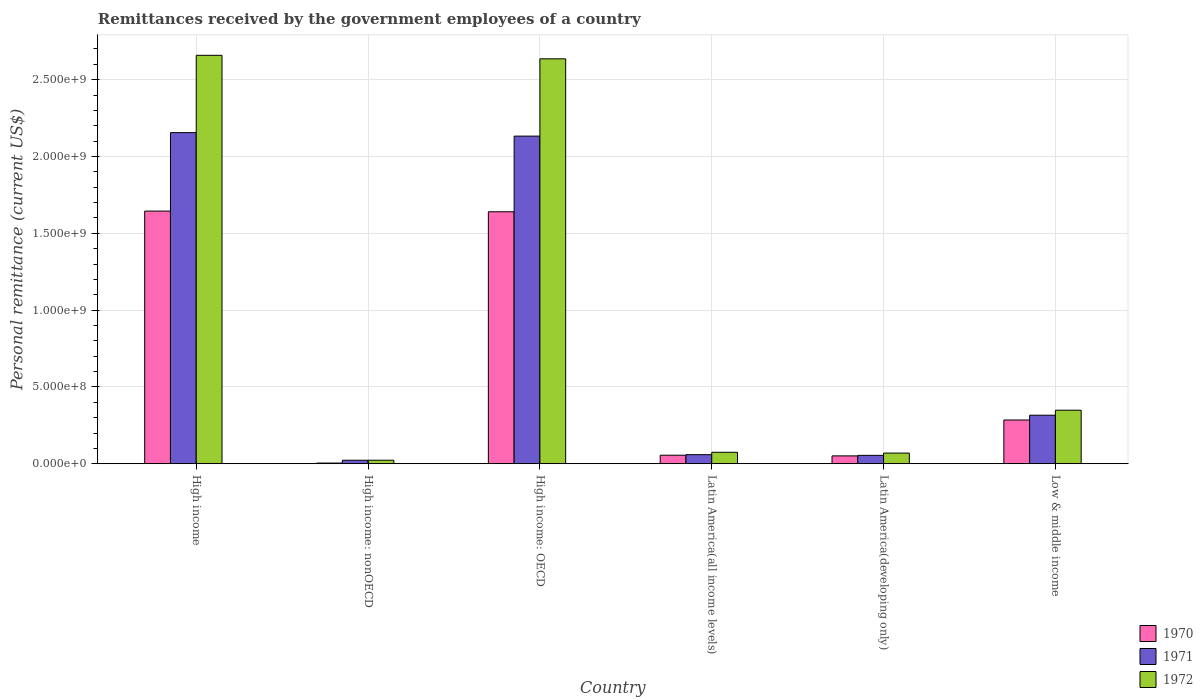Are the number of bars per tick equal to the number of legend labels?
Ensure brevity in your answer.  Yes. How many bars are there on the 4th tick from the right?
Your answer should be compact. 3. What is the label of the 5th group of bars from the left?
Provide a succinct answer. Latin America(developing only). What is the remittances received by the government employees in 1970 in High income: nonOECD?
Provide a succinct answer. 4.40e+06. Across all countries, what is the maximum remittances received by the government employees in 1971?
Keep it short and to the point. 2.16e+09. Across all countries, what is the minimum remittances received by the government employees in 1971?
Ensure brevity in your answer.  2.28e+07. In which country was the remittances received by the government employees in 1970 maximum?
Give a very brief answer. High income. In which country was the remittances received by the government employees in 1970 minimum?
Your answer should be very brief. High income: nonOECD. What is the total remittances received by the government employees in 1971 in the graph?
Give a very brief answer. 4.74e+09. What is the difference between the remittances received by the government employees in 1972 in High income: OECD and that in Latin America(all income levels)?
Your response must be concise. 2.56e+09. What is the difference between the remittances received by the government employees in 1972 in Latin America(developing only) and the remittances received by the government employees in 1971 in High income: OECD?
Your answer should be compact. -2.06e+09. What is the average remittances received by the government employees in 1972 per country?
Your answer should be very brief. 9.68e+08. What is the difference between the remittances received by the government employees of/in 1970 and remittances received by the government employees of/in 1972 in High income?
Your answer should be very brief. -1.01e+09. In how many countries, is the remittances received by the government employees in 1972 greater than 100000000 US$?
Offer a very short reply. 3. What is the ratio of the remittances received by the government employees in 1972 in High income to that in Latin America(developing only)?
Your answer should be very brief. 38.32. Is the remittances received by the government employees in 1970 in Latin America(all income levels) less than that in Low & middle income?
Provide a succinct answer. Yes. Is the difference between the remittances received by the government employees in 1970 in High income and Low & middle income greater than the difference between the remittances received by the government employees in 1972 in High income and Low & middle income?
Make the answer very short. No. What is the difference between the highest and the second highest remittances received by the government employees in 1970?
Make the answer very short. -1.36e+09. What is the difference between the highest and the lowest remittances received by the government employees in 1970?
Keep it short and to the point. 1.64e+09. Is the sum of the remittances received by the government employees in 1971 in High income and Latin America(all income levels) greater than the maximum remittances received by the government employees in 1972 across all countries?
Offer a terse response. No. What does the 1st bar from the left in Low & middle income represents?
Your answer should be very brief. 1970. Is it the case that in every country, the sum of the remittances received by the government employees in 1971 and remittances received by the government employees in 1970 is greater than the remittances received by the government employees in 1972?
Provide a short and direct response. Yes. How many bars are there?
Make the answer very short. 18. How many countries are there in the graph?
Ensure brevity in your answer.  6. What is the difference between two consecutive major ticks on the Y-axis?
Offer a very short reply. 5.00e+08. Are the values on the major ticks of Y-axis written in scientific E-notation?
Offer a terse response. Yes. Does the graph contain grids?
Give a very brief answer. Yes. Where does the legend appear in the graph?
Provide a succinct answer. Bottom right. How many legend labels are there?
Offer a terse response. 3. How are the legend labels stacked?
Your answer should be very brief. Vertical. What is the title of the graph?
Make the answer very short. Remittances received by the government employees of a country. What is the label or title of the X-axis?
Make the answer very short. Country. What is the label or title of the Y-axis?
Your answer should be very brief. Personal remittance (current US$). What is the Personal remittance (current US$) in 1970 in High income?
Provide a succinct answer. 1.64e+09. What is the Personal remittance (current US$) in 1971 in High income?
Give a very brief answer. 2.16e+09. What is the Personal remittance (current US$) of 1972 in High income?
Your answer should be compact. 2.66e+09. What is the Personal remittance (current US$) of 1970 in High income: nonOECD?
Give a very brief answer. 4.40e+06. What is the Personal remittance (current US$) of 1971 in High income: nonOECD?
Keep it short and to the point. 2.28e+07. What is the Personal remittance (current US$) of 1972 in High income: nonOECD?
Your response must be concise. 2.29e+07. What is the Personal remittance (current US$) in 1970 in High income: OECD?
Your answer should be compact. 1.64e+09. What is the Personal remittance (current US$) in 1971 in High income: OECD?
Offer a terse response. 2.13e+09. What is the Personal remittance (current US$) in 1972 in High income: OECD?
Provide a succinct answer. 2.64e+09. What is the Personal remittance (current US$) in 1970 in Latin America(all income levels)?
Ensure brevity in your answer.  5.55e+07. What is the Personal remittance (current US$) in 1971 in Latin America(all income levels)?
Give a very brief answer. 5.91e+07. What is the Personal remittance (current US$) in 1972 in Latin America(all income levels)?
Offer a terse response. 7.45e+07. What is the Personal remittance (current US$) in 1970 in Latin America(developing only)?
Your answer should be very brief. 5.11e+07. What is the Personal remittance (current US$) in 1971 in Latin America(developing only)?
Keep it short and to the point. 5.45e+07. What is the Personal remittance (current US$) of 1972 in Latin America(developing only)?
Make the answer very short. 6.94e+07. What is the Personal remittance (current US$) in 1970 in Low & middle income?
Your answer should be compact. 2.85e+08. What is the Personal remittance (current US$) of 1971 in Low & middle income?
Offer a terse response. 3.16e+08. What is the Personal remittance (current US$) in 1972 in Low & middle income?
Your answer should be compact. 3.48e+08. Across all countries, what is the maximum Personal remittance (current US$) of 1970?
Offer a terse response. 1.64e+09. Across all countries, what is the maximum Personal remittance (current US$) of 1971?
Your answer should be very brief. 2.16e+09. Across all countries, what is the maximum Personal remittance (current US$) in 1972?
Keep it short and to the point. 2.66e+09. Across all countries, what is the minimum Personal remittance (current US$) of 1970?
Ensure brevity in your answer.  4.40e+06. Across all countries, what is the minimum Personal remittance (current US$) in 1971?
Keep it short and to the point. 2.28e+07. Across all countries, what is the minimum Personal remittance (current US$) of 1972?
Offer a terse response. 2.29e+07. What is the total Personal remittance (current US$) of 1970 in the graph?
Keep it short and to the point. 3.68e+09. What is the total Personal remittance (current US$) of 1971 in the graph?
Your response must be concise. 4.74e+09. What is the total Personal remittance (current US$) in 1972 in the graph?
Offer a terse response. 5.81e+09. What is the difference between the Personal remittance (current US$) of 1970 in High income and that in High income: nonOECD?
Ensure brevity in your answer.  1.64e+09. What is the difference between the Personal remittance (current US$) in 1971 in High income and that in High income: nonOECD?
Provide a short and direct response. 2.13e+09. What is the difference between the Personal remittance (current US$) of 1972 in High income and that in High income: nonOECD?
Offer a very short reply. 2.64e+09. What is the difference between the Personal remittance (current US$) of 1970 in High income and that in High income: OECD?
Provide a succinct answer. 4.40e+06. What is the difference between the Personal remittance (current US$) in 1971 in High income and that in High income: OECD?
Keep it short and to the point. 2.28e+07. What is the difference between the Personal remittance (current US$) of 1972 in High income and that in High income: OECD?
Your answer should be very brief. 2.29e+07. What is the difference between the Personal remittance (current US$) in 1970 in High income and that in Latin America(all income levels)?
Your answer should be very brief. 1.59e+09. What is the difference between the Personal remittance (current US$) of 1971 in High income and that in Latin America(all income levels)?
Offer a terse response. 2.10e+09. What is the difference between the Personal remittance (current US$) in 1972 in High income and that in Latin America(all income levels)?
Offer a very short reply. 2.58e+09. What is the difference between the Personal remittance (current US$) in 1970 in High income and that in Latin America(developing only)?
Ensure brevity in your answer.  1.59e+09. What is the difference between the Personal remittance (current US$) in 1971 in High income and that in Latin America(developing only)?
Offer a very short reply. 2.10e+09. What is the difference between the Personal remittance (current US$) in 1972 in High income and that in Latin America(developing only)?
Ensure brevity in your answer.  2.59e+09. What is the difference between the Personal remittance (current US$) in 1970 in High income and that in Low & middle income?
Provide a short and direct response. 1.36e+09. What is the difference between the Personal remittance (current US$) in 1971 in High income and that in Low & middle income?
Offer a terse response. 1.84e+09. What is the difference between the Personal remittance (current US$) in 1972 in High income and that in Low & middle income?
Keep it short and to the point. 2.31e+09. What is the difference between the Personal remittance (current US$) in 1970 in High income: nonOECD and that in High income: OECD?
Provide a short and direct response. -1.64e+09. What is the difference between the Personal remittance (current US$) in 1971 in High income: nonOECD and that in High income: OECD?
Keep it short and to the point. -2.11e+09. What is the difference between the Personal remittance (current US$) of 1972 in High income: nonOECD and that in High income: OECD?
Offer a terse response. -2.61e+09. What is the difference between the Personal remittance (current US$) of 1970 in High income: nonOECD and that in Latin America(all income levels)?
Provide a short and direct response. -5.11e+07. What is the difference between the Personal remittance (current US$) of 1971 in High income: nonOECD and that in Latin America(all income levels)?
Offer a terse response. -3.63e+07. What is the difference between the Personal remittance (current US$) of 1972 in High income: nonOECD and that in Latin America(all income levels)?
Give a very brief answer. -5.16e+07. What is the difference between the Personal remittance (current US$) of 1970 in High income: nonOECD and that in Latin America(developing only)?
Provide a short and direct response. -4.67e+07. What is the difference between the Personal remittance (current US$) in 1971 in High income: nonOECD and that in Latin America(developing only)?
Make the answer very short. -3.17e+07. What is the difference between the Personal remittance (current US$) in 1972 in High income: nonOECD and that in Latin America(developing only)?
Offer a very short reply. -4.65e+07. What is the difference between the Personal remittance (current US$) in 1970 in High income: nonOECD and that in Low & middle income?
Keep it short and to the point. -2.80e+08. What is the difference between the Personal remittance (current US$) of 1971 in High income: nonOECD and that in Low & middle income?
Offer a very short reply. -2.93e+08. What is the difference between the Personal remittance (current US$) in 1972 in High income: nonOECD and that in Low & middle income?
Provide a succinct answer. -3.26e+08. What is the difference between the Personal remittance (current US$) of 1970 in High income: OECD and that in Latin America(all income levels)?
Your answer should be very brief. 1.58e+09. What is the difference between the Personal remittance (current US$) in 1971 in High income: OECD and that in Latin America(all income levels)?
Your answer should be very brief. 2.07e+09. What is the difference between the Personal remittance (current US$) in 1972 in High income: OECD and that in Latin America(all income levels)?
Your answer should be very brief. 2.56e+09. What is the difference between the Personal remittance (current US$) of 1970 in High income: OECD and that in Latin America(developing only)?
Ensure brevity in your answer.  1.59e+09. What is the difference between the Personal remittance (current US$) of 1971 in High income: OECD and that in Latin America(developing only)?
Your answer should be very brief. 2.08e+09. What is the difference between the Personal remittance (current US$) in 1972 in High income: OECD and that in Latin America(developing only)?
Your response must be concise. 2.57e+09. What is the difference between the Personal remittance (current US$) in 1970 in High income: OECD and that in Low & middle income?
Your answer should be compact. 1.36e+09. What is the difference between the Personal remittance (current US$) in 1971 in High income: OECD and that in Low & middle income?
Provide a succinct answer. 1.82e+09. What is the difference between the Personal remittance (current US$) of 1972 in High income: OECD and that in Low & middle income?
Keep it short and to the point. 2.29e+09. What is the difference between the Personal remittance (current US$) in 1970 in Latin America(all income levels) and that in Latin America(developing only)?
Provide a short and direct response. 4.40e+06. What is the difference between the Personal remittance (current US$) of 1971 in Latin America(all income levels) and that in Latin America(developing only)?
Give a very brief answer. 4.61e+06. What is the difference between the Personal remittance (current US$) of 1972 in Latin America(all income levels) and that in Latin America(developing only)?
Ensure brevity in your answer.  5.10e+06. What is the difference between the Personal remittance (current US$) in 1970 in Latin America(all income levels) and that in Low & middle income?
Make the answer very short. -2.29e+08. What is the difference between the Personal remittance (current US$) in 1971 in Latin America(all income levels) and that in Low & middle income?
Ensure brevity in your answer.  -2.57e+08. What is the difference between the Personal remittance (current US$) in 1972 in Latin America(all income levels) and that in Low & middle income?
Your answer should be very brief. -2.74e+08. What is the difference between the Personal remittance (current US$) in 1970 in Latin America(developing only) and that in Low & middle income?
Offer a terse response. -2.34e+08. What is the difference between the Personal remittance (current US$) of 1971 in Latin America(developing only) and that in Low & middle income?
Your answer should be compact. -2.61e+08. What is the difference between the Personal remittance (current US$) in 1972 in Latin America(developing only) and that in Low & middle income?
Keep it short and to the point. -2.79e+08. What is the difference between the Personal remittance (current US$) of 1970 in High income and the Personal remittance (current US$) of 1971 in High income: nonOECD?
Provide a short and direct response. 1.62e+09. What is the difference between the Personal remittance (current US$) of 1970 in High income and the Personal remittance (current US$) of 1972 in High income: nonOECD?
Provide a short and direct response. 1.62e+09. What is the difference between the Personal remittance (current US$) of 1971 in High income and the Personal remittance (current US$) of 1972 in High income: nonOECD?
Give a very brief answer. 2.13e+09. What is the difference between the Personal remittance (current US$) in 1970 in High income and the Personal remittance (current US$) in 1971 in High income: OECD?
Your answer should be compact. -4.88e+08. What is the difference between the Personal remittance (current US$) of 1970 in High income and the Personal remittance (current US$) of 1972 in High income: OECD?
Give a very brief answer. -9.91e+08. What is the difference between the Personal remittance (current US$) of 1971 in High income and the Personal remittance (current US$) of 1972 in High income: OECD?
Offer a terse response. -4.80e+08. What is the difference between the Personal remittance (current US$) in 1970 in High income and the Personal remittance (current US$) in 1971 in Latin America(all income levels)?
Ensure brevity in your answer.  1.59e+09. What is the difference between the Personal remittance (current US$) in 1970 in High income and the Personal remittance (current US$) in 1972 in Latin America(all income levels)?
Offer a terse response. 1.57e+09. What is the difference between the Personal remittance (current US$) of 1971 in High income and the Personal remittance (current US$) of 1972 in Latin America(all income levels)?
Your answer should be very brief. 2.08e+09. What is the difference between the Personal remittance (current US$) in 1970 in High income and the Personal remittance (current US$) in 1971 in Latin America(developing only)?
Offer a very short reply. 1.59e+09. What is the difference between the Personal remittance (current US$) in 1970 in High income and the Personal remittance (current US$) in 1972 in Latin America(developing only)?
Offer a terse response. 1.58e+09. What is the difference between the Personal remittance (current US$) of 1971 in High income and the Personal remittance (current US$) of 1972 in Latin America(developing only)?
Offer a very short reply. 2.09e+09. What is the difference between the Personal remittance (current US$) in 1970 in High income and the Personal remittance (current US$) in 1971 in Low & middle income?
Your response must be concise. 1.33e+09. What is the difference between the Personal remittance (current US$) of 1970 in High income and the Personal remittance (current US$) of 1972 in Low & middle income?
Ensure brevity in your answer.  1.30e+09. What is the difference between the Personal remittance (current US$) of 1971 in High income and the Personal remittance (current US$) of 1972 in Low & middle income?
Your answer should be very brief. 1.81e+09. What is the difference between the Personal remittance (current US$) of 1970 in High income: nonOECD and the Personal remittance (current US$) of 1971 in High income: OECD?
Your response must be concise. -2.13e+09. What is the difference between the Personal remittance (current US$) of 1970 in High income: nonOECD and the Personal remittance (current US$) of 1972 in High income: OECD?
Your response must be concise. -2.63e+09. What is the difference between the Personal remittance (current US$) of 1971 in High income: nonOECD and the Personal remittance (current US$) of 1972 in High income: OECD?
Provide a short and direct response. -2.61e+09. What is the difference between the Personal remittance (current US$) of 1970 in High income: nonOECD and the Personal remittance (current US$) of 1971 in Latin America(all income levels)?
Your response must be concise. -5.47e+07. What is the difference between the Personal remittance (current US$) of 1970 in High income: nonOECD and the Personal remittance (current US$) of 1972 in Latin America(all income levels)?
Give a very brief answer. -7.01e+07. What is the difference between the Personal remittance (current US$) in 1971 in High income: nonOECD and the Personal remittance (current US$) in 1972 in Latin America(all income levels)?
Give a very brief answer. -5.17e+07. What is the difference between the Personal remittance (current US$) in 1970 in High income: nonOECD and the Personal remittance (current US$) in 1971 in Latin America(developing only)?
Your response must be concise. -5.01e+07. What is the difference between the Personal remittance (current US$) in 1970 in High income: nonOECD and the Personal remittance (current US$) in 1972 in Latin America(developing only)?
Give a very brief answer. -6.50e+07. What is the difference between the Personal remittance (current US$) of 1971 in High income: nonOECD and the Personal remittance (current US$) of 1972 in Latin America(developing only)?
Give a very brief answer. -4.66e+07. What is the difference between the Personal remittance (current US$) in 1970 in High income: nonOECD and the Personal remittance (current US$) in 1971 in Low & middle income?
Give a very brief answer. -3.11e+08. What is the difference between the Personal remittance (current US$) in 1970 in High income: nonOECD and the Personal remittance (current US$) in 1972 in Low & middle income?
Your answer should be compact. -3.44e+08. What is the difference between the Personal remittance (current US$) of 1971 in High income: nonOECD and the Personal remittance (current US$) of 1972 in Low & middle income?
Keep it short and to the point. -3.26e+08. What is the difference between the Personal remittance (current US$) in 1970 in High income: OECD and the Personal remittance (current US$) in 1971 in Latin America(all income levels)?
Give a very brief answer. 1.58e+09. What is the difference between the Personal remittance (current US$) in 1970 in High income: OECD and the Personal remittance (current US$) in 1972 in Latin America(all income levels)?
Make the answer very short. 1.57e+09. What is the difference between the Personal remittance (current US$) of 1971 in High income: OECD and the Personal remittance (current US$) of 1972 in Latin America(all income levels)?
Your answer should be compact. 2.06e+09. What is the difference between the Personal remittance (current US$) in 1970 in High income: OECD and the Personal remittance (current US$) in 1971 in Latin America(developing only)?
Your answer should be compact. 1.59e+09. What is the difference between the Personal remittance (current US$) in 1970 in High income: OECD and the Personal remittance (current US$) in 1972 in Latin America(developing only)?
Keep it short and to the point. 1.57e+09. What is the difference between the Personal remittance (current US$) of 1971 in High income: OECD and the Personal remittance (current US$) of 1972 in Latin America(developing only)?
Your answer should be compact. 2.06e+09. What is the difference between the Personal remittance (current US$) in 1970 in High income: OECD and the Personal remittance (current US$) in 1971 in Low & middle income?
Offer a very short reply. 1.32e+09. What is the difference between the Personal remittance (current US$) in 1970 in High income: OECD and the Personal remittance (current US$) in 1972 in Low & middle income?
Offer a terse response. 1.29e+09. What is the difference between the Personal remittance (current US$) of 1971 in High income: OECD and the Personal remittance (current US$) of 1972 in Low & middle income?
Provide a succinct answer. 1.78e+09. What is the difference between the Personal remittance (current US$) of 1970 in Latin America(all income levels) and the Personal remittance (current US$) of 1971 in Latin America(developing only)?
Your answer should be very brief. 1.03e+06. What is the difference between the Personal remittance (current US$) in 1970 in Latin America(all income levels) and the Personal remittance (current US$) in 1972 in Latin America(developing only)?
Keep it short and to the point. -1.39e+07. What is the difference between the Personal remittance (current US$) of 1971 in Latin America(all income levels) and the Personal remittance (current US$) of 1972 in Latin America(developing only)?
Make the answer very short. -1.03e+07. What is the difference between the Personal remittance (current US$) in 1970 in Latin America(all income levels) and the Personal remittance (current US$) in 1971 in Low & middle income?
Your answer should be compact. -2.60e+08. What is the difference between the Personal remittance (current US$) in 1970 in Latin America(all income levels) and the Personal remittance (current US$) in 1972 in Low & middle income?
Provide a succinct answer. -2.93e+08. What is the difference between the Personal remittance (current US$) in 1971 in Latin America(all income levels) and the Personal remittance (current US$) in 1972 in Low & middle income?
Offer a very short reply. -2.89e+08. What is the difference between the Personal remittance (current US$) in 1970 in Latin America(developing only) and the Personal remittance (current US$) in 1971 in Low & middle income?
Provide a succinct answer. -2.65e+08. What is the difference between the Personal remittance (current US$) in 1970 in Latin America(developing only) and the Personal remittance (current US$) in 1972 in Low & middle income?
Your answer should be compact. -2.97e+08. What is the difference between the Personal remittance (current US$) of 1971 in Latin America(developing only) and the Personal remittance (current US$) of 1972 in Low & middle income?
Your answer should be very brief. -2.94e+08. What is the average Personal remittance (current US$) in 1970 per country?
Your answer should be compact. 6.13e+08. What is the average Personal remittance (current US$) in 1971 per country?
Your answer should be very brief. 7.90e+08. What is the average Personal remittance (current US$) in 1972 per country?
Ensure brevity in your answer.  9.68e+08. What is the difference between the Personal remittance (current US$) of 1970 and Personal remittance (current US$) of 1971 in High income?
Keep it short and to the point. -5.11e+08. What is the difference between the Personal remittance (current US$) of 1970 and Personal remittance (current US$) of 1972 in High income?
Give a very brief answer. -1.01e+09. What is the difference between the Personal remittance (current US$) of 1971 and Personal remittance (current US$) of 1972 in High income?
Give a very brief answer. -5.03e+08. What is the difference between the Personal remittance (current US$) of 1970 and Personal remittance (current US$) of 1971 in High income: nonOECD?
Offer a very short reply. -1.84e+07. What is the difference between the Personal remittance (current US$) of 1970 and Personal remittance (current US$) of 1972 in High income: nonOECD?
Ensure brevity in your answer.  -1.85e+07. What is the difference between the Personal remittance (current US$) of 1971 and Personal remittance (current US$) of 1972 in High income: nonOECD?
Provide a short and direct response. -1.37e+05. What is the difference between the Personal remittance (current US$) of 1970 and Personal remittance (current US$) of 1971 in High income: OECD?
Make the answer very short. -4.92e+08. What is the difference between the Personal remittance (current US$) of 1970 and Personal remittance (current US$) of 1972 in High income: OECD?
Make the answer very short. -9.96e+08. What is the difference between the Personal remittance (current US$) in 1971 and Personal remittance (current US$) in 1972 in High income: OECD?
Your answer should be very brief. -5.03e+08. What is the difference between the Personal remittance (current US$) of 1970 and Personal remittance (current US$) of 1971 in Latin America(all income levels)?
Provide a short and direct response. -3.57e+06. What is the difference between the Personal remittance (current US$) of 1970 and Personal remittance (current US$) of 1972 in Latin America(all income levels)?
Offer a terse response. -1.90e+07. What is the difference between the Personal remittance (current US$) in 1971 and Personal remittance (current US$) in 1972 in Latin America(all income levels)?
Offer a terse response. -1.54e+07. What is the difference between the Personal remittance (current US$) in 1970 and Personal remittance (current US$) in 1971 in Latin America(developing only)?
Provide a short and direct response. -3.37e+06. What is the difference between the Personal remittance (current US$) of 1970 and Personal remittance (current US$) of 1972 in Latin America(developing only)?
Make the answer very short. -1.83e+07. What is the difference between the Personal remittance (current US$) in 1971 and Personal remittance (current US$) in 1972 in Latin America(developing only)?
Provide a succinct answer. -1.49e+07. What is the difference between the Personal remittance (current US$) in 1970 and Personal remittance (current US$) in 1971 in Low & middle income?
Your answer should be very brief. -3.11e+07. What is the difference between the Personal remittance (current US$) of 1970 and Personal remittance (current US$) of 1972 in Low & middle income?
Keep it short and to the point. -6.37e+07. What is the difference between the Personal remittance (current US$) of 1971 and Personal remittance (current US$) of 1972 in Low & middle income?
Give a very brief answer. -3.25e+07. What is the ratio of the Personal remittance (current US$) in 1970 in High income to that in High income: nonOECD?
Offer a terse response. 373.75. What is the ratio of the Personal remittance (current US$) in 1971 in High income to that in High income: nonOECD?
Make the answer very short. 94.6. What is the ratio of the Personal remittance (current US$) of 1972 in High income to that in High income: nonOECD?
Make the answer very short. 115.99. What is the ratio of the Personal remittance (current US$) of 1971 in High income to that in High income: OECD?
Offer a terse response. 1.01. What is the ratio of the Personal remittance (current US$) in 1972 in High income to that in High income: OECD?
Make the answer very short. 1.01. What is the ratio of the Personal remittance (current US$) in 1970 in High income to that in Latin America(all income levels)?
Your answer should be compact. 29.63. What is the ratio of the Personal remittance (current US$) of 1971 in High income to that in Latin America(all income levels)?
Offer a terse response. 36.49. What is the ratio of the Personal remittance (current US$) in 1972 in High income to that in Latin America(all income levels)?
Provide a short and direct response. 35.7. What is the ratio of the Personal remittance (current US$) in 1970 in High income to that in Latin America(developing only)?
Your response must be concise. 32.18. What is the ratio of the Personal remittance (current US$) in 1971 in High income to that in Latin America(developing only)?
Keep it short and to the point. 39.57. What is the ratio of the Personal remittance (current US$) of 1972 in High income to that in Latin America(developing only)?
Ensure brevity in your answer.  38.32. What is the ratio of the Personal remittance (current US$) in 1970 in High income to that in Low & middle income?
Your answer should be very brief. 5.78. What is the ratio of the Personal remittance (current US$) of 1971 in High income to that in Low & middle income?
Provide a succinct answer. 6.82. What is the ratio of the Personal remittance (current US$) of 1972 in High income to that in Low & middle income?
Your response must be concise. 7.63. What is the ratio of the Personal remittance (current US$) in 1970 in High income: nonOECD to that in High income: OECD?
Make the answer very short. 0. What is the ratio of the Personal remittance (current US$) of 1971 in High income: nonOECD to that in High income: OECD?
Provide a short and direct response. 0.01. What is the ratio of the Personal remittance (current US$) in 1972 in High income: nonOECD to that in High income: OECD?
Make the answer very short. 0.01. What is the ratio of the Personal remittance (current US$) of 1970 in High income: nonOECD to that in Latin America(all income levels)?
Provide a short and direct response. 0.08. What is the ratio of the Personal remittance (current US$) in 1971 in High income: nonOECD to that in Latin America(all income levels)?
Your answer should be very brief. 0.39. What is the ratio of the Personal remittance (current US$) of 1972 in High income: nonOECD to that in Latin America(all income levels)?
Offer a very short reply. 0.31. What is the ratio of the Personal remittance (current US$) of 1970 in High income: nonOECD to that in Latin America(developing only)?
Your answer should be compact. 0.09. What is the ratio of the Personal remittance (current US$) of 1971 in High income: nonOECD to that in Latin America(developing only)?
Make the answer very short. 0.42. What is the ratio of the Personal remittance (current US$) in 1972 in High income: nonOECD to that in Latin America(developing only)?
Provide a short and direct response. 0.33. What is the ratio of the Personal remittance (current US$) in 1970 in High income: nonOECD to that in Low & middle income?
Offer a terse response. 0.02. What is the ratio of the Personal remittance (current US$) in 1971 in High income: nonOECD to that in Low & middle income?
Your answer should be very brief. 0.07. What is the ratio of the Personal remittance (current US$) in 1972 in High income: nonOECD to that in Low & middle income?
Provide a short and direct response. 0.07. What is the ratio of the Personal remittance (current US$) of 1970 in High income: OECD to that in Latin America(all income levels)?
Give a very brief answer. 29.55. What is the ratio of the Personal remittance (current US$) in 1971 in High income: OECD to that in Latin America(all income levels)?
Make the answer very short. 36.1. What is the ratio of the Personal remittance (current US$) of 1972 in High income: OECD to that in Latin America(all income levels)?
Provide a succinct answer. 35.39. What is the ratio of the Personal remittance (current US$) of 1970 in High income: OECD to that in Latin America(developing only)?
Offer a very short reply. 32.1. What is the ratio of the Personal remittance (current US$) of 1971 in High income: OECD to that in Latin America(developing only)?
Your answer should be very brief. 39.15. What is the ratio of the Personal remittance (current US$) in 1972 in High income: OECD to that in Latin America(developing only)?
Provide a short and direct response. 37.99. What is the ratio of the Personal remittance (current US$) of 1970 in High income: OECD to that in Low & middle income?
Offer a very short reply. 5.76. What is the ratio of the Personal remittance (current US$) of 1971 in High income: OECD to that in Low & middle income?
Ensure brevity in your answer.  6.75. What is the ratio of the Personal remittance (current US$) in 1972 in High income: OECD to that in Low & middle income?
Offer a terse response. 7.56. What is the ratio of the Personal remittance (current US$) in 1970 in Latin America(all income levels) to that in Latin America(developing only)?
Your response must be concise. 1.09. What is the ratio of the Personal remittance (current US$) of 1971 in Latin America(all income levels) to that in Latin America(developing only)?
Provide a succinct answer. 1.08. What is the ratio of the Personal remittance (current US$) of 1972 in Latin America(all income levels) to that in Latin America(developing only)?
Provide a short and direct response. 1.07. What is the ratio of the Personal remittance (current US$) of 1970 in Latin America(all income levels) to that in Low & middle income?
Keep it short and to the point. 0.19. What is the ratio of the Personal remittance (current US$) of 1971 in Latin America(all income levels) to that in Low & middle income?
Your answer should be compact. 0.19. What is the ratio of the Personal remittance (current US$) of 1972 in Latin America(all income levels) to that in Low & middle income?
Your answer should be compact. 0.21. What is the ratio of the Personal remittance (current US$) in 1970 in Latin America(developing only) to that in Low & middle income?
Your answer should be very brief. 0.18. What is the ratio of the Personal remittance (current US$) in 1971 in Latin America(developing only) to that in Low & middle income?
Offer a very short reply. 0.17. What is the ratio of the Personal remittance (current US$) in 1972 in Latin America(developing only) to that in Low & middle income?
Your response must be concise. 0.2. What is the difference between the highest and the second highest Personal remittance (current US$) of 1970?
Make the answer very short. 4.40e+06. What is the difference between the highest and the second highest Personal remittance (current US$) of 1971?
Your response must be concise. 2.28e+07. What is the difference between the highest and the second highest Personal remittance (current US$) in 1972?
Your response must be concise. 2.29e+07. What is the difference between the highest and the lowest Personal remittance (current US$) of 1970?
Provide a short and direct response. 1.64e+09. What is the difference between the highest and the lowest Personal remittance (current US$) of 1971?
Ensure brevity in your answer.  2.13e+09. What is the difference between the highest and the lowest Personal remittance (current US$) of 1972?
Provide a short and direct response. 2.64e+09. 